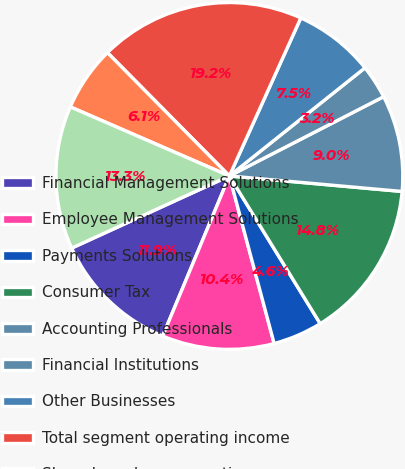Convert chart. <chart><loc_0><loc_0><loc_500><loc_500><pie_chart><fcel>Financial Management Solutions<fcel>Employee Management Solutions<fcel>Payments Solutions<fcel>Consumer Tax<fcel>Accounting Professionals<fcel>Financial Institutions<fcel>Other Businesses<fcel>Total segment operating income<fcel>Share-based compensation<fcel>Other common expenses<nl><fcel>11.89%<fcel>10.44%<fcel>4.62%<fcel>14.8%<fcel>8.98%<fcel>3.16%<fcel>7.53%<fcel>19.17%<fcel>6.07%<fcel>13.35%<nl></chart> 